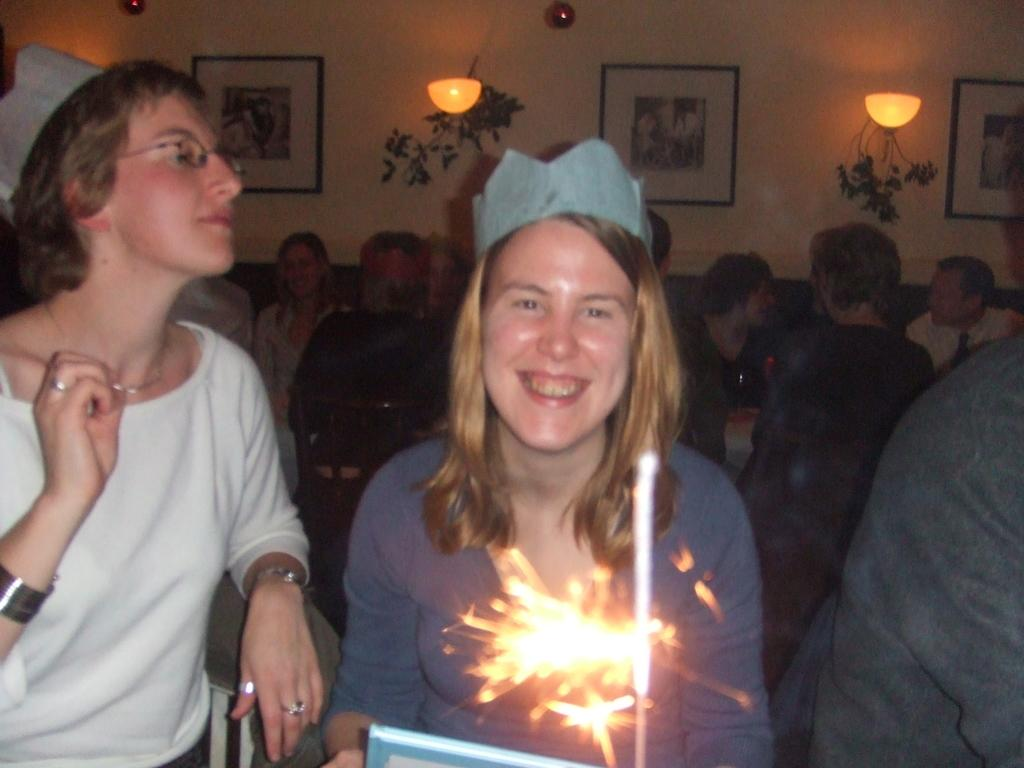What can be seen in the foreground of the image? There is a sparkle in the foreground of the image. What is visible in the background of the image? There are people, frames, and plants in the background of the image. Can you describe the people in the background? The provided facts do not give specific details about the people in the background, so we cannot describe them. What type of wood is used to create the existence of the position in the image? There is no wood, existence, or position mentioned in the image. The image features a sparkle in the foreground and people, frames, and plants in the background. 